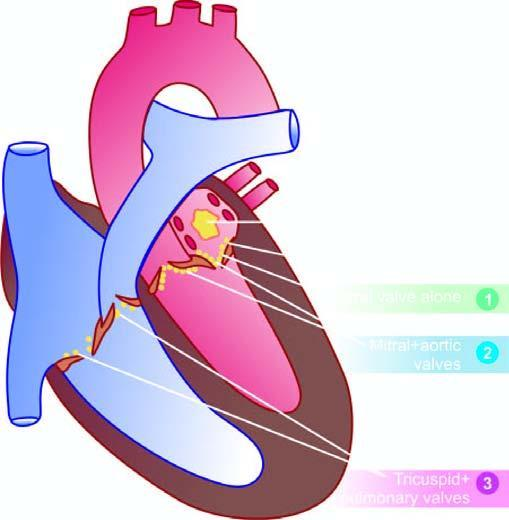re 2 and 3 denoted for the frequency of valvular involvement?
Answer the question using a single word or phrase. Yes 